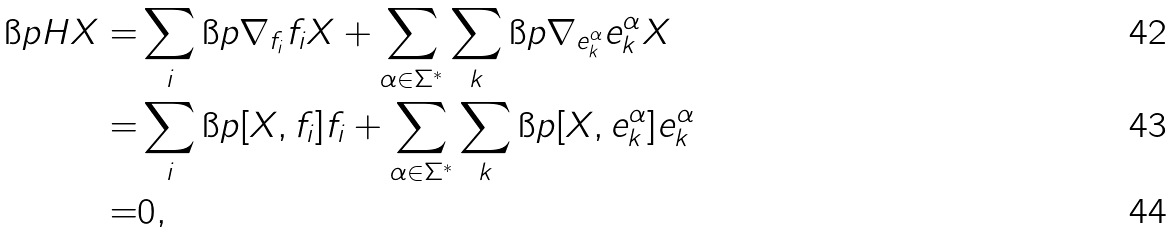Convert formula to latex. <formula><loc_0><loc_0><loc_500><loc_500>\i p H X = & \sum _ { i } \i p { \nabla _ { f _ { i } } f _ { i } } { X } + \sum _ { \alpha \in \Sigma ^ { * } } \sum _ { k } \i p { \nabla _ { e _ { k } ^ { \alpha } } e _ { k } ^ { \alpha } } { X } \\ = & \sum _ { i } \i p { [ X , f _ { i } ] } { f _ { i } } + \sum _ { \alpha \in \Sigma ^ { * } } \sum _ { k } \i p { [ X , e _ { k } ^ { \alpha } ] } { e _ { k } ^ { \alpha } } \\ = & 0 ,</formula> 